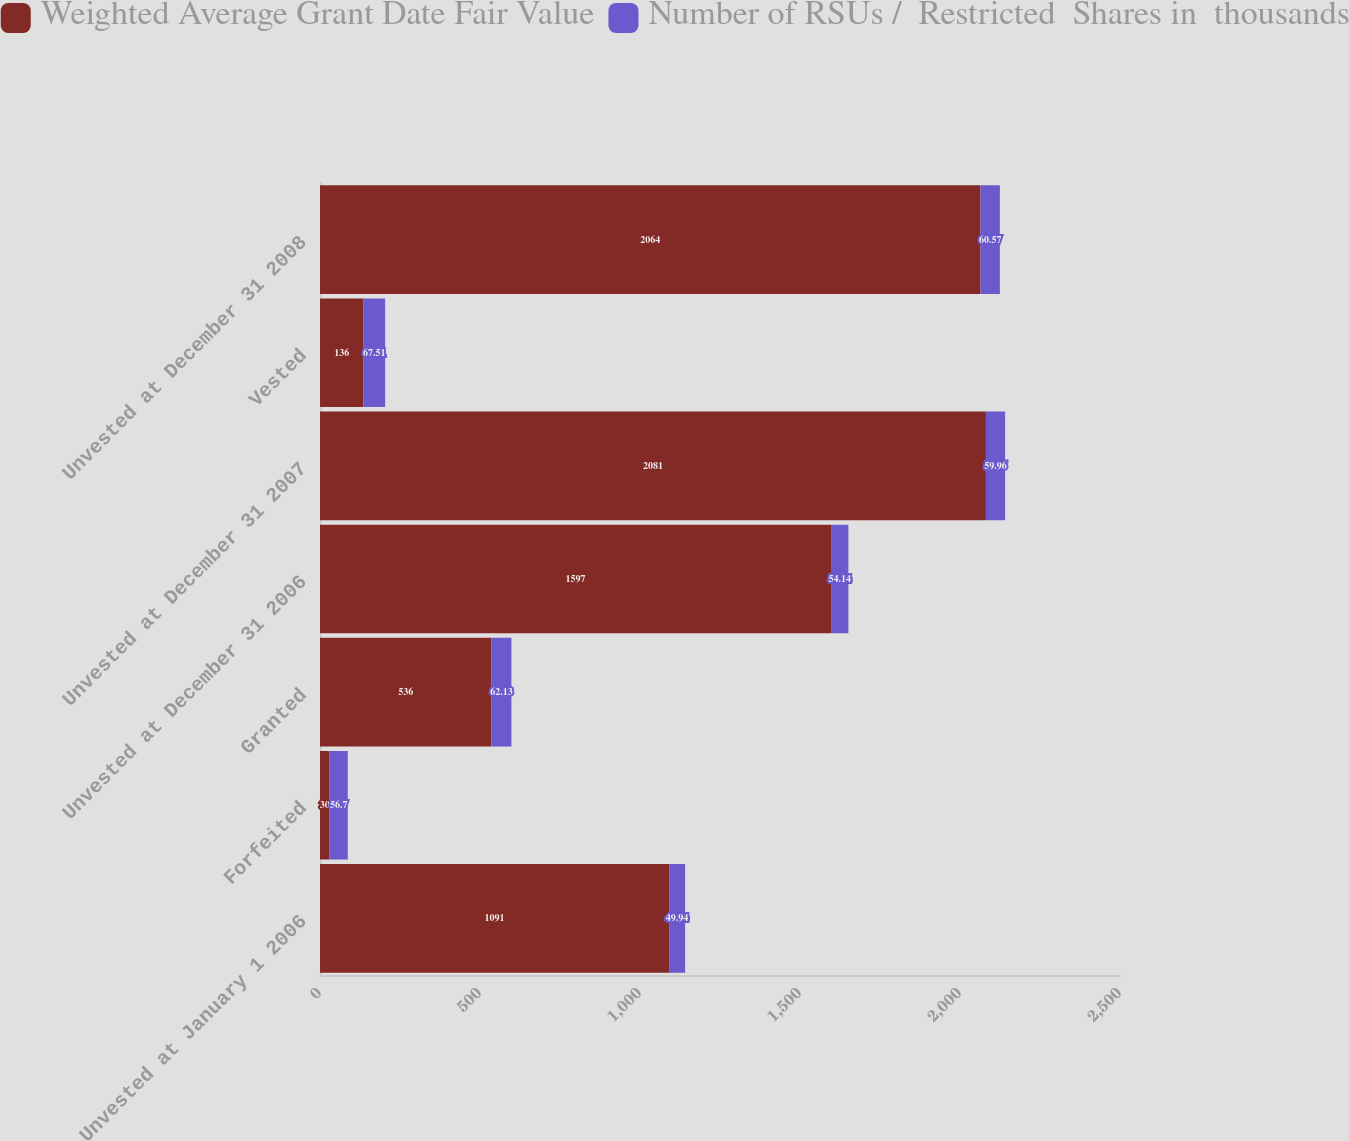<chart> <loc_0><loc_0><loc_500><loc_500><stacked_bar_chart><ecel><fcel>Unvested at January 1 2006<fcel>Forfeited<fcel>Granted<fcel>Unvested at December 31 2006<fcel>Unvested at December 31 2007<fcel>Vested<fcel>Unvested at December 31 2008<nl><fcel>Weighted Average Grant Date Fair Value<fcel>1091<fcel>30<fcel>536<fcel>1597<fcel>2081<fcel>136<fcel>2064<nl><fcel>Number of RSUs /  Restricted  Shares in  thousands<fcel>49.94<fcel>56.7<fcel>62.13<fcel>54.14<fcel>59.96<fcel>67.51<fcel>60.57<nl></chart> 